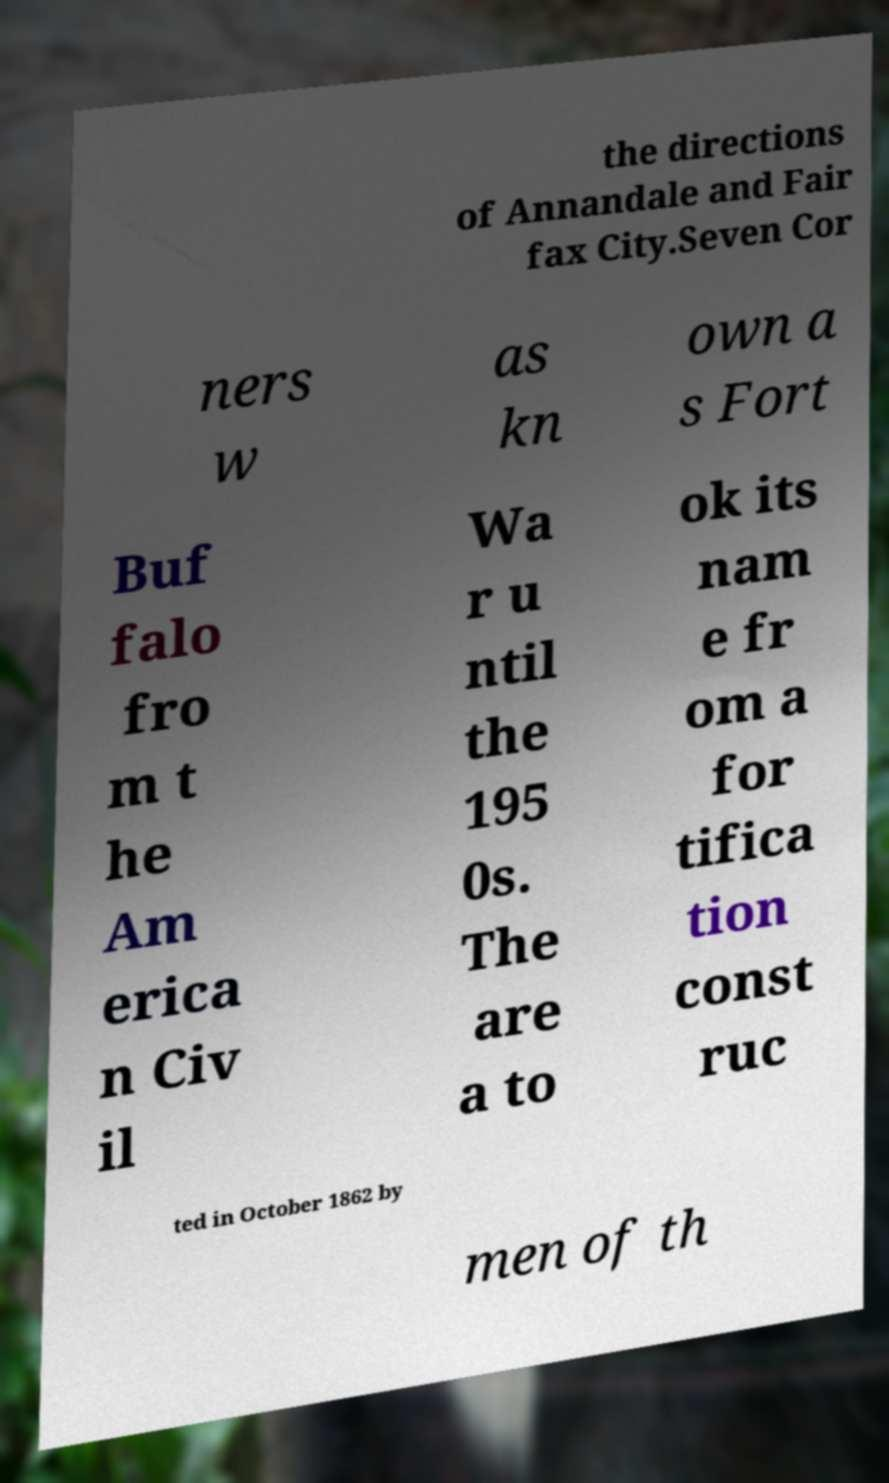For documentation purposes, I need the text within this image transcribed. Could you provide that? the directions of Annandale and Fair fax City.Seven Cor ners w as kn own a s Fort Buf falo fro m t he Am erica n Civ il Wa r u ntil the 195 0s. The are a to ok its nam e fr om a for tifica tion const ruc ted in October 1862 by men of th 